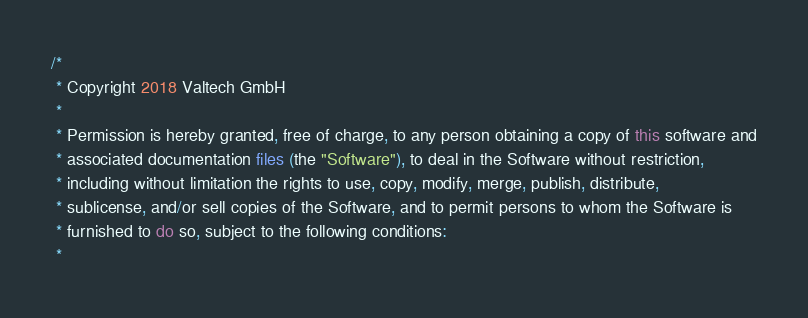Convert code to text. <code><loc_0><loc_0><loc_500><loc_500><_Java_>/*
 * Copyright 2018 Valtech GmbH
 *
 * Permission is hereby granted, free of charge, to any person obtaining a copy of this software and
 * associated documentation files (the "Software"), to deal in the Software without restriction,
 * including without limitation the rights to use, copy, modify, merge, publish, distribute,
 * sublicense, and/or sell copies of the Software, and to permit persons to whom the Software is
 * furnished to do so, subject to the following conditions:
 *</code> 